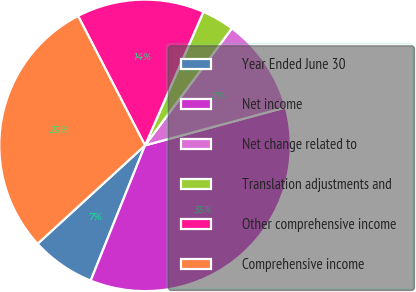<chart> <loc_0><loc_0><loc_500><loc_500><pie_chart><fcel>Year Ended June 30<fcel>Net income<fcel>Net change related to<fcel>Translation adjustments and<fcel>Other comprehensive income<fcel>Comprehensive income<nl><fcel>7.12%<fcel>35.28%<fcel>10.64%<fcel>3.6%<fcel>14.16%<fcel>29.2%<nl></chart> 